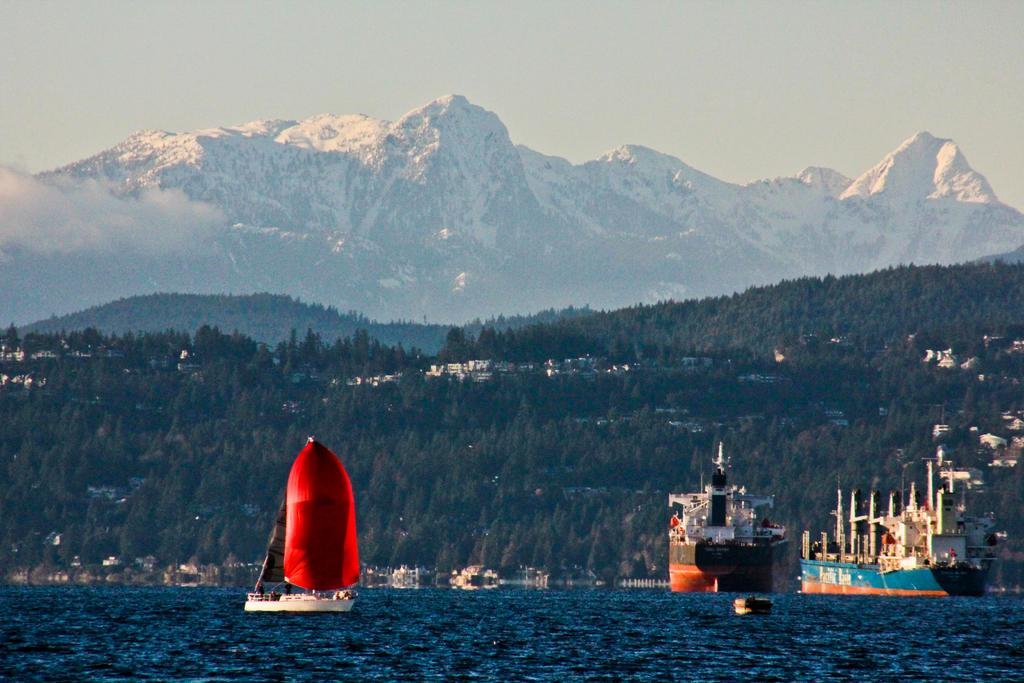What type of water body can be seen in the image? There are ships in a large water body in the image. What else can be seen in the image besides the water body? There are buildings, a group of trees, and ice hills visible in the image. What is the condition of the sky in the image? The sky appears cloudy in the image. Can you tell me how many buttons are on the dog in the image? There is no dog or button present in the image. 